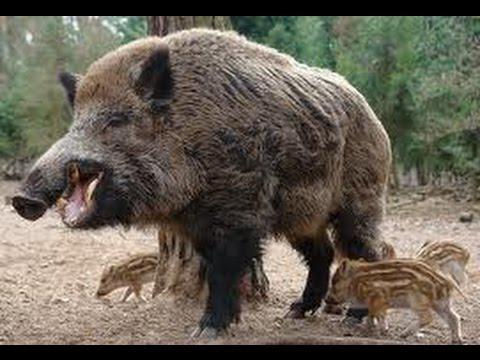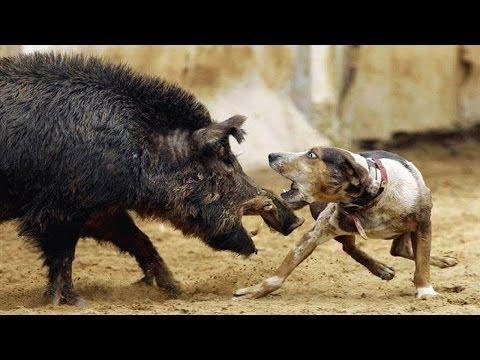The first image is the image on the left, the second image is the image on the right. For the images shown, is this caption "At least one image shows an animal fighting with the boar." true? Answer yes or no. Yes. The first image is the image on the left, the second image is the image on the right. Assess this claim about the two images: "One of the image features one man next to a dead wild boar.". Correct or not? Answer yes or no. No. 